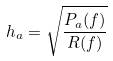<formula> <loc_0><loc_0><loc_500><loc_500>h _ { a } = \sqrt { \frac { P _ { a } ( f ) } { R ( f ) } }</formula> 